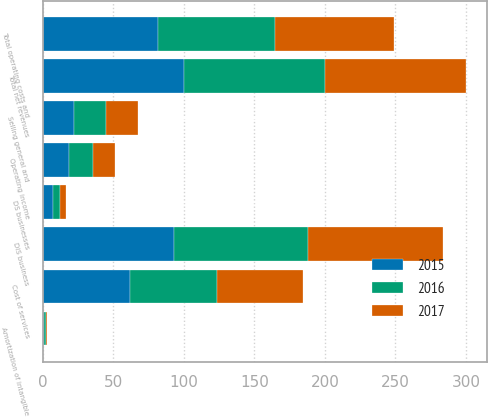<chart> <loc_0><loc_0><loc_500><loc_500><stacked_bar_chart><ecel><fcel>DIS business<fcel>DS businesses<fcel>Total net revenues<fcel>Cost of services<fcel>Selling general and<fcel>Amortization of intangible<fcel>Total operating costs and<fcel>Operating income<nl><fcel>2017<fcel>95.6<fcel>4.4<fcel>100<fcel>61.2<fcel>22.7<fcel>1<fcel>84.9<fcel>15.1<nl><fcel>2016<fcel>95<fcel>5<fcel>100<fcel>61.4<fcel>22.4<fcel>1<fcel>83<fcel>17<nl><fcel>2015<fcel>93<fcel>7<fcel>100<fcel>62.1<fcel>22.4<fcel>1.1<fcel>81.3<fcel>18.7<nl></chart> 